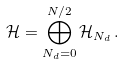<formula> <loc_0><loc_0><loc_500><loc_500>\mathcal { H } = \bigoplus _ { N _ { d } = 0 } ^ { N / 2 } \mathcal { H } _ { N _ { d } } \, .</formula> 